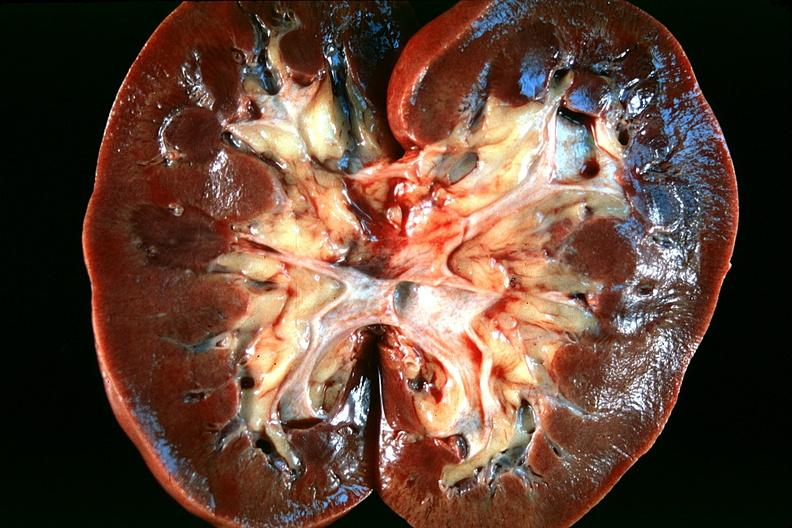where is this?
Answer the question using a single word or phrase. Urinary 